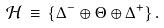<formula> <loc_0><loc_0><loc_500><loc_500>\mathcal { H } \, \equiv \, \{ \Delta ^ { - } \oplus \Theta \oplus \Delta ^ { + } \} \, .</formula> 